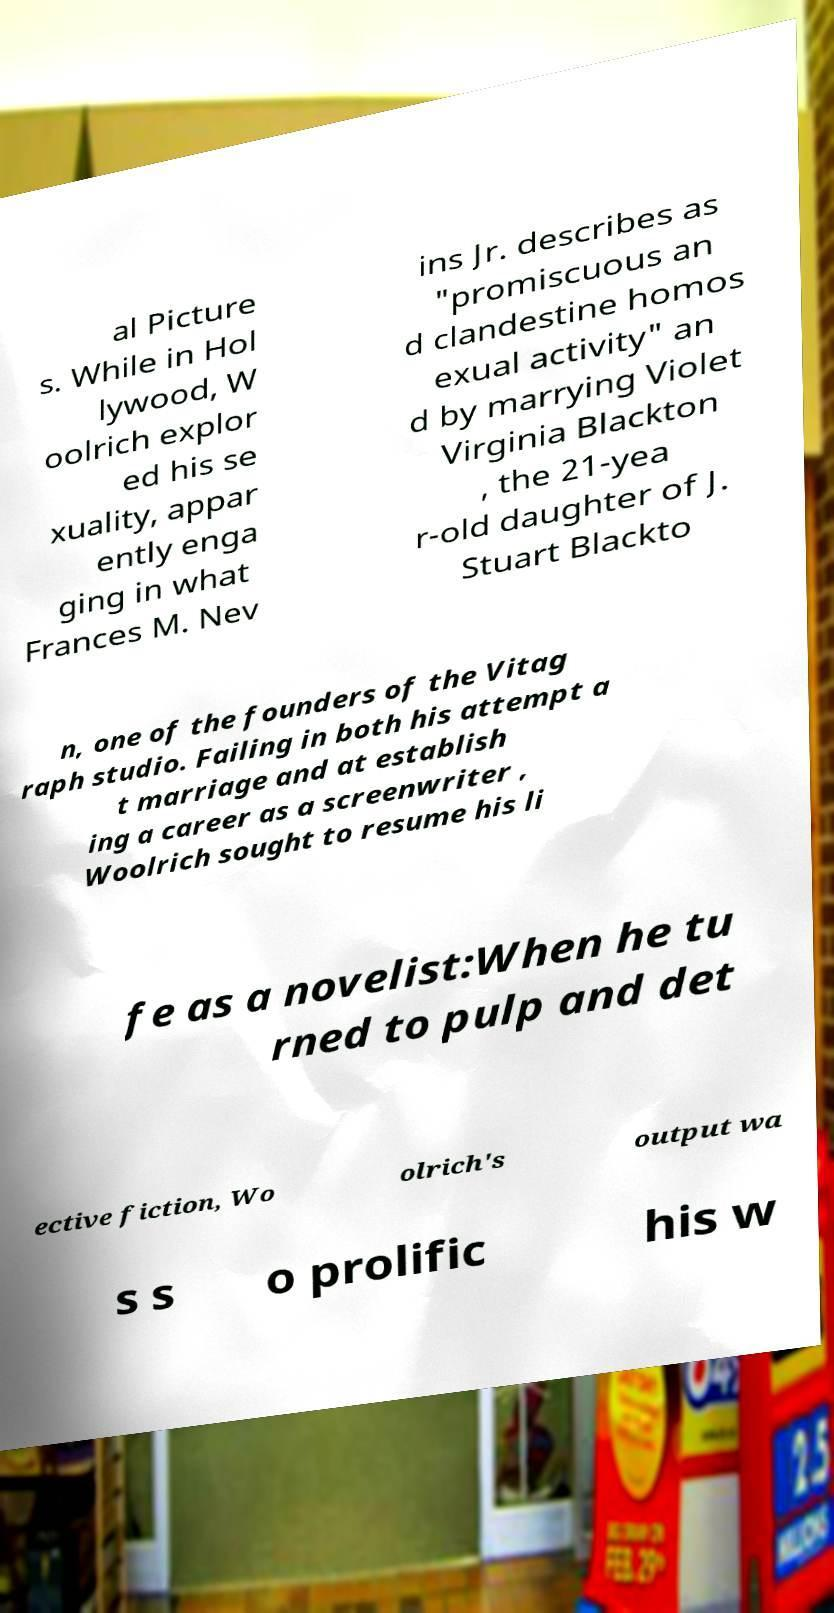Please identify and transcribe the text found in this image. al Picture s. While in Hol lywood, W oolrich explor ed his se xuality, appar ently enga ging in what Frances M. Nev ins Jr. describes as "promiscuous an d clandestine homos exual activity" an d by marrying Violet Virginia Blackton , the 21-yea r-old daughter of J. Stuart Blackto n, one of the founders of the Vitag raph studio. Failing in both his attempt a t marriage and at establish ing a career as a screenwriter , Woolrich sought to resume his li fe as a novelist:When he tu rned to pulp and det ective fiction, Wo olrich's output wa s s o prolific his w 